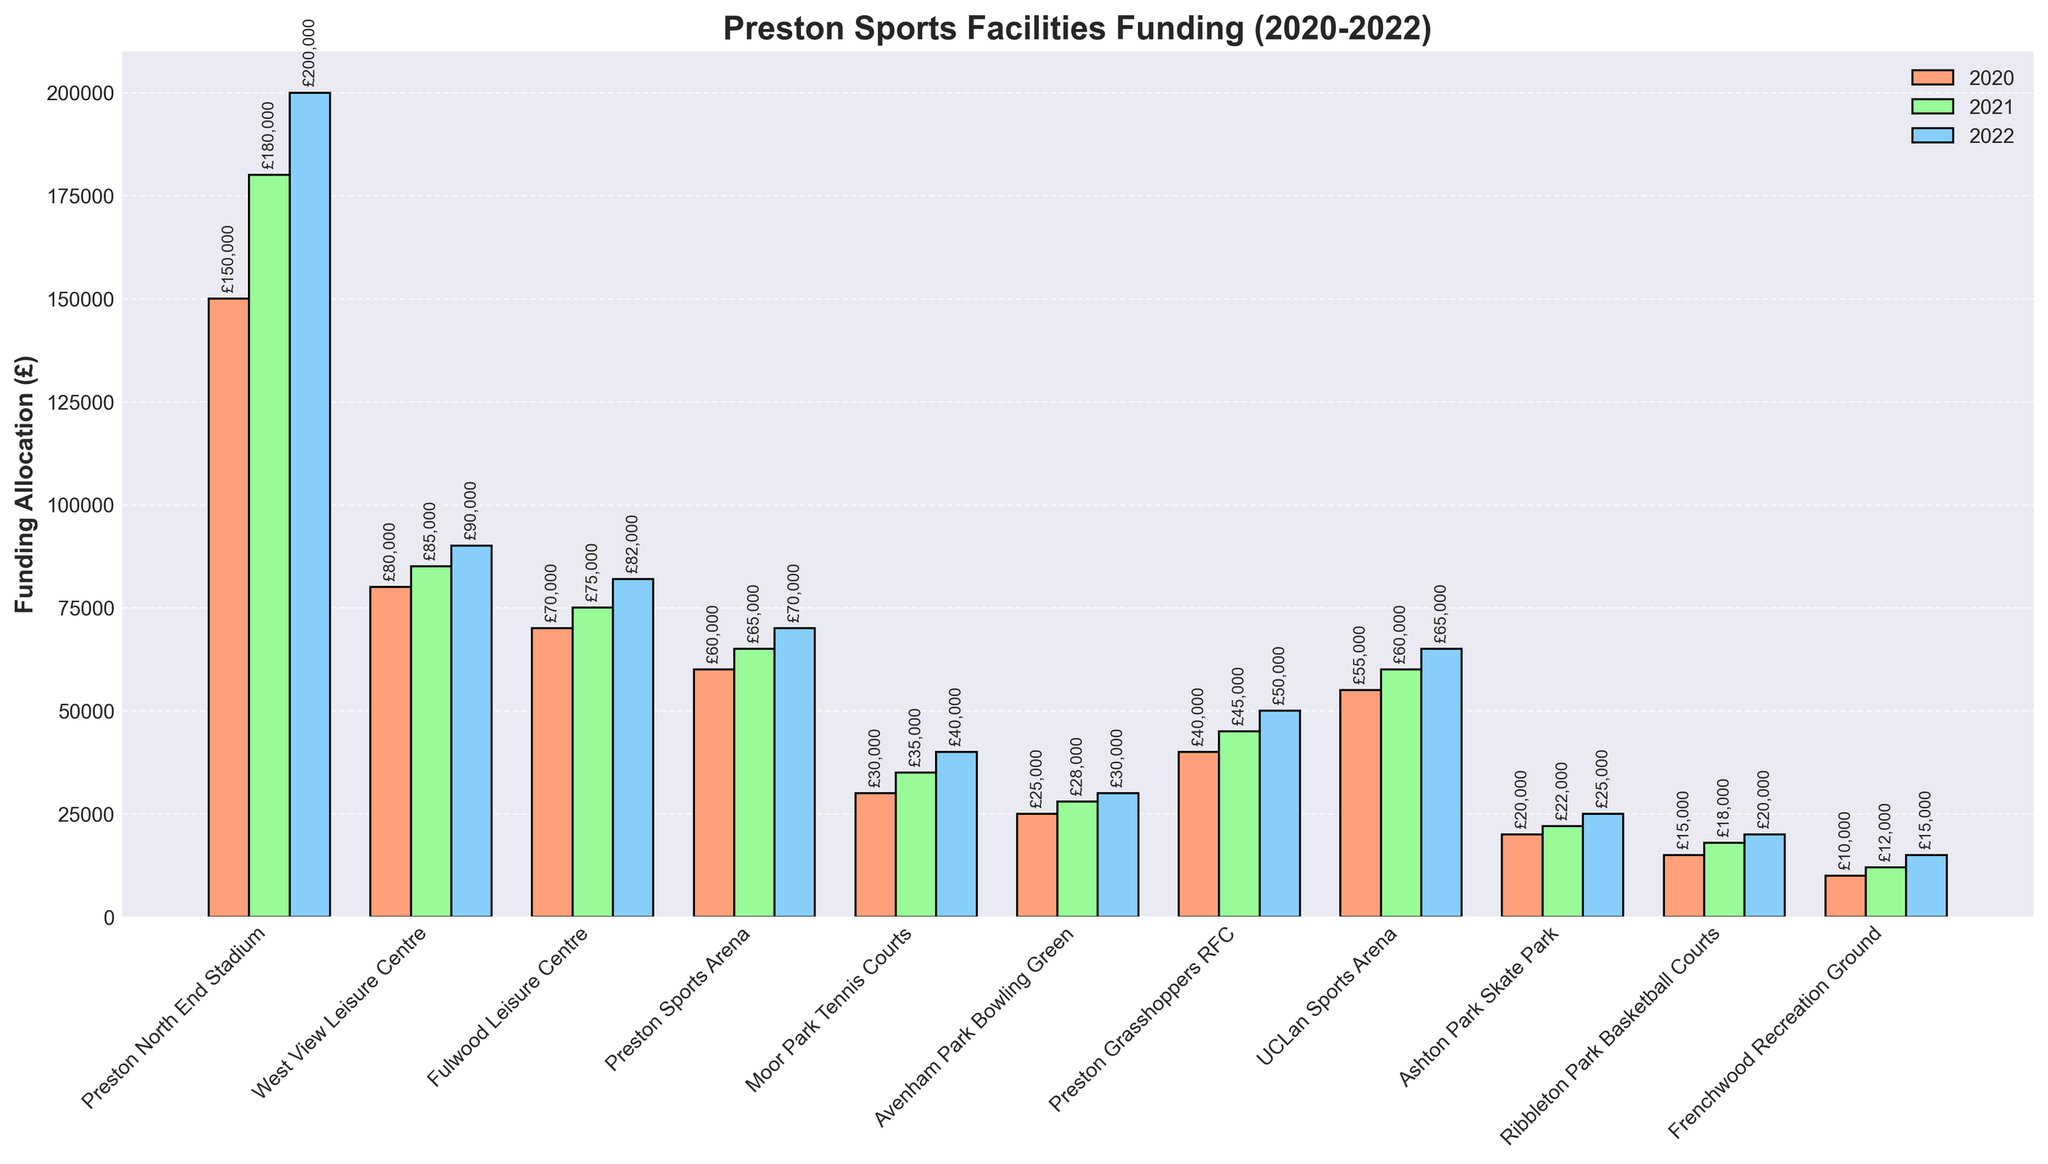Which facility received the most funding in 2022? By looking at the heights of the bars for 2022, the Preston North End Stadium has the highest bar.
Answer: Preston North End Stadium What is the total funding allocated to Preston North End Stadium over the three years? Adding the yearly funding values for Preston North End Stadium: £150,000 (2020) + £180,000 (2021) + £200,000 (2022) = £530,000
Answer: £530,000 Which facility saw the largest increase in funding from 2020 to 2022? Calculating the difference for each facility from 2020 to 2022 and comparing them, the Preston North End Stadium had an increase of £50,000.
Answer: Preston North End Stadium Compare the funding for Ribbleton Park Basketball Courts and Frenchwood Recreation Ground in 2022. Which received more, and by how much? Ribbleton Park Basketball Courts received £20,000 in 2022 and Frenchwood Recreation Ground received £15,000. The difference is £20,000 - £15,000 = £5,000, so Ribbleton received £5,000 more.
Answer: Ribbleton Park Basketball Courts by £5,000 How has the funding for Fulwood Leisure Centre changed from 2020 to 2022? The funding for Fulwood Leisure Centre in 2020 was £70,000, in 2021 it was £75,000, and in 2022 it was £82,000, showing a steady increase each year.
Answer: Steady increase Which year had the lowest total funding across all facilities? Sum the funding for all facilities for each year:
2020: £150,000 + £80,000 + £70,000 + £60,000 + £30,000 + £25,000 + £40,000 + £55,000 + £20,000 + £15,000 + £10,000 = £555,000  
2021: £180,000 + £85,000 + £75,000 + £65,000 + £35,000 + £28,000 + £45,000 + £60,000 + £22,000 + £18,000 + £12,000 = £625,000  
2022: £200,000 + £90,000 + £82,000 + £70,000 + £40,000 + £30,000 + £50,000 + £65,000 + £25,000 + £20,000 + £15,000 = £687,000  
The year with the lowest total funding is 2020.
Answer: 2020 What's the difference in total funding for UCLan Sports Arena from 2020 to 2022? Calculate the difference: £65,000 (2022) - £55,000 (2020) = £10,000
Answer: £10,000 Which facility had the smallest increase in funding between 2020 and 2022? By comparing the increases for each facility, Avenham Park Bowling Green went from £25,000 to £30,000, an increase of £5,000, which is the smallest increase.
Answer: Avenham Park Bowling Green Is there any facility that received consistent funding in all three years? From the chart, no facility shows exactly the same funding amount for all three years.
Answer: No 